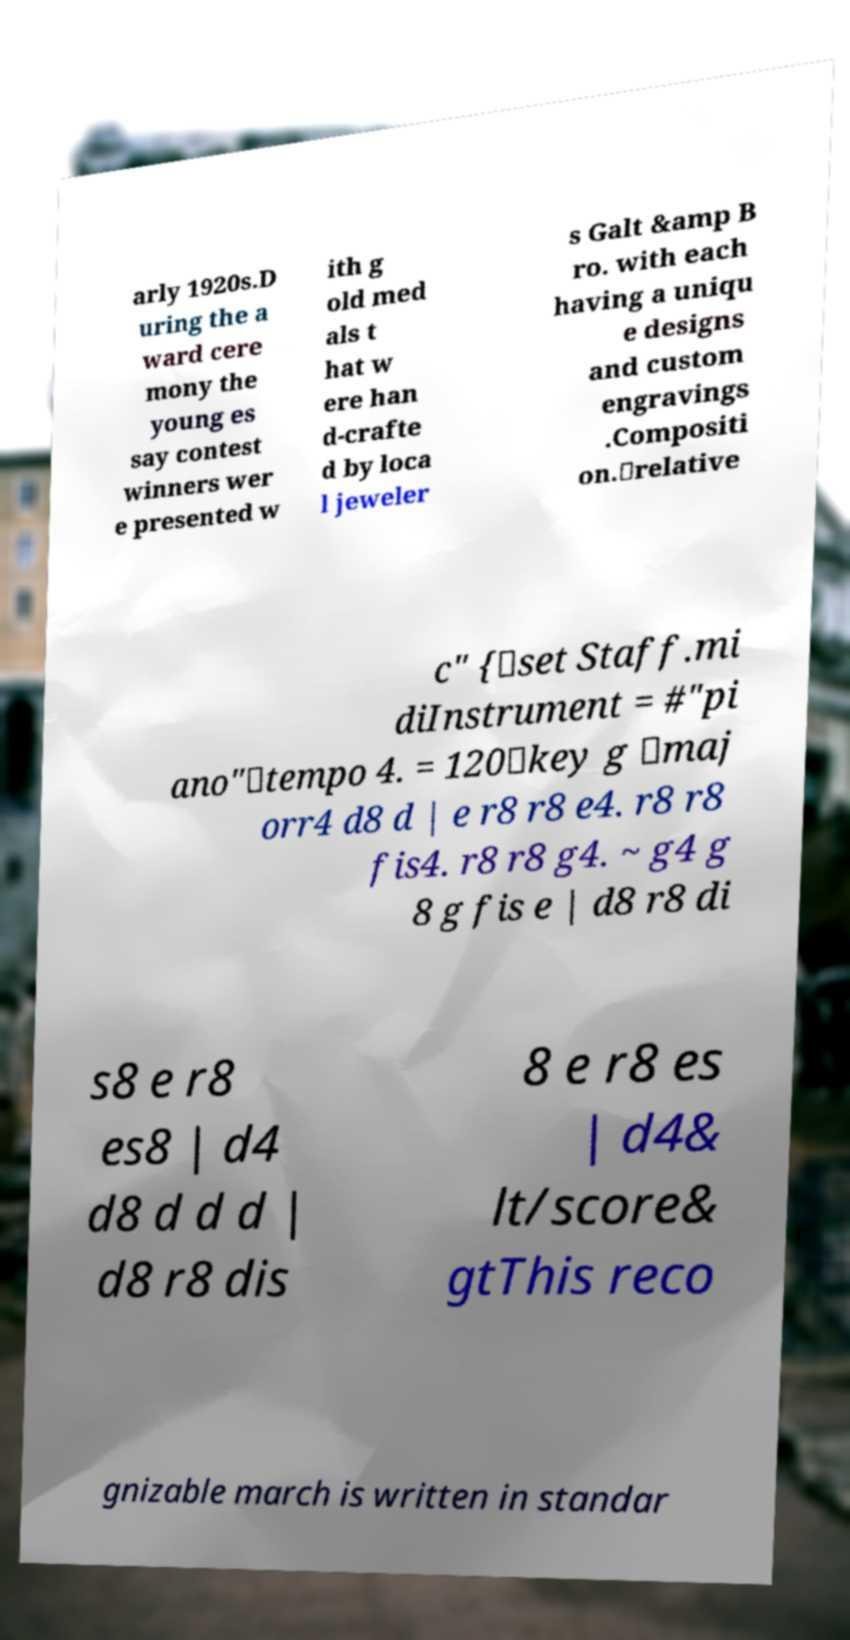Can you read and provide the text displayed in the image?This photo seems to have some interesting text. Can you extract and type it out for me? arly 1920s.D uring the a ward cere mony the young es say contest winners wer e presented w ith g old med als t hat w ere han d-crafte d by loca l jeweler s Galt &amp B ro. with each having a uniqu e designs and custom engravings .Compositi on.\relative c" {\set Staff.mi diInstrument = #"pi ano"\tempo 4. = 120\key g \maj orr4 d8 d | e r8 r8 e4. r8 r8 fis4. r8 r8 g4. ~ g4 g 8 g fis e | d8 r8 di s8 e r8 es8 | d4 d8 d d d | d8 r8 dis 8 e r8 es | d4& lt/score& gtThis reco gnizable march is written in standar 